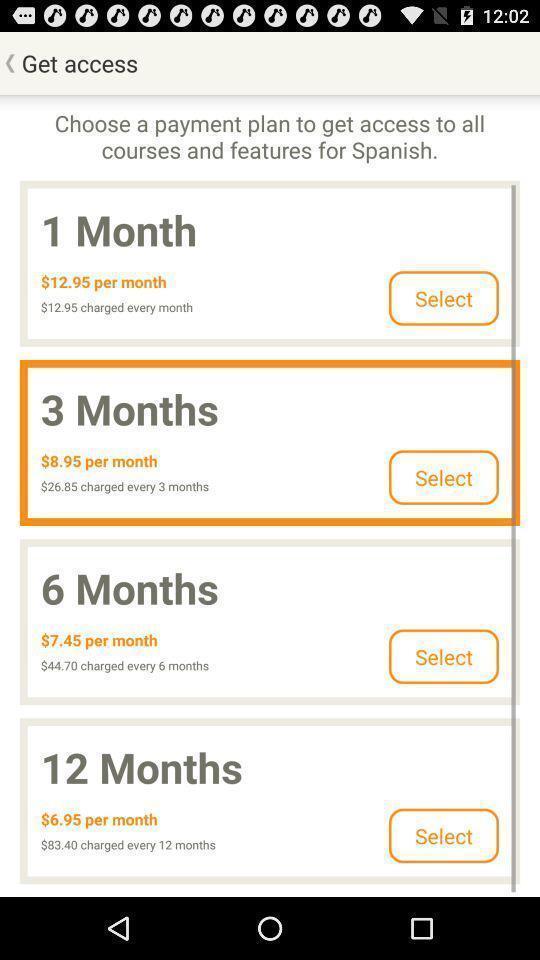Describe the content in this image. Screen displaying multiple payment plans with price details. 